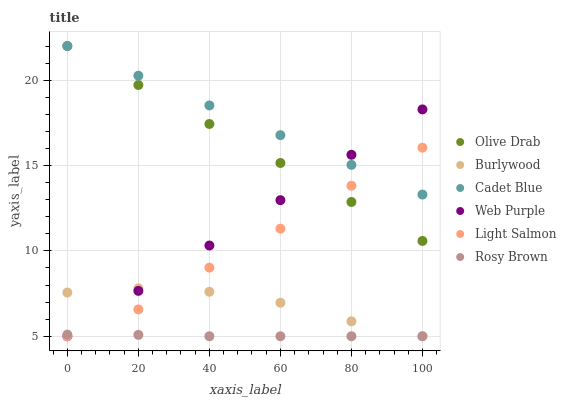Does Rosy Brown have the minimum area under the curve?
Answer yes or no. Yes. Does Cadet Blue have the maximum area under the curve?
Answer yes or no. Yes. Does Burlywood have the minimum area under the curve?
Answer yes or no. No. Does Burlywood have the maximum area under the curve?
Answer yes or no. No. Is Olive Drab the smoothest?
Answer yes or no. Yes. Is Light Salmon the roughest?
Answer yes or no. Yes. Is Cadet Blue the smoothest?
Answer yes or no. No. Is Cadet Blue the roughest?
Answer yes or no. No. Does Light Salmon have the lowest value?
Answer yes or no. Yes. Does Cadet Blue have the lowest value?
Answer yes or no. No. Does Olive Drab have the highest value?
Answer yes or no. Yes. Does Burlywood have the highest value?
Answer yes or no. No. Is Rosy Brown less than Olive Drab?
Answer yes or no. Yes. Is Cadet Blue greater than Rosy Brown?
Answer yes or no. Yes. Does Cadet Blue intersect Olive Drab?
Answer yes or no. Yes. Is Cadet Blue less than Olive Drab?
Answer yes or no. No. Is Cadet Blue greater than Olive Drab?
Answer yes or no. No. Does Rosy Brown intersect Olive Drab?
Answer yes or no. No. 